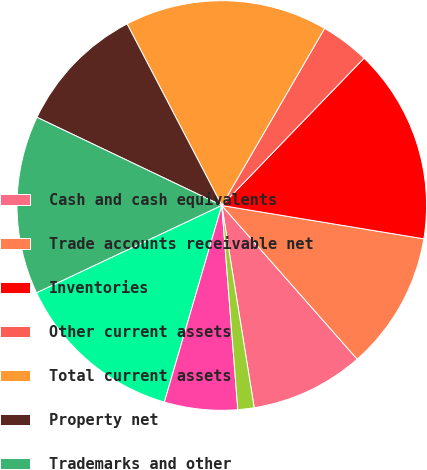Convert chart. <chart><loc_0><loc_0><loc_500><loc_500><pie_chart><fcel>Cash and cash equivalents<fcel>Trade accounts receivable net<fcel>Inventories<fcel>Other current assets<fcel>Total current assets<fcel>Property net<fcel>Trademarks and other<fcel>Goodwill<fcel>Deferred tax assets<fcel>Other noncurrent assets<nl><fcel>8.97%<fcel>10.9%<fcel>15.38%<fcel>3.85%<fcel>16.02%<fcel>10.26%<fcel>14.1%<fcel>13.46%<fcel>5.77%<fcel>1.28%<nl></chart> 